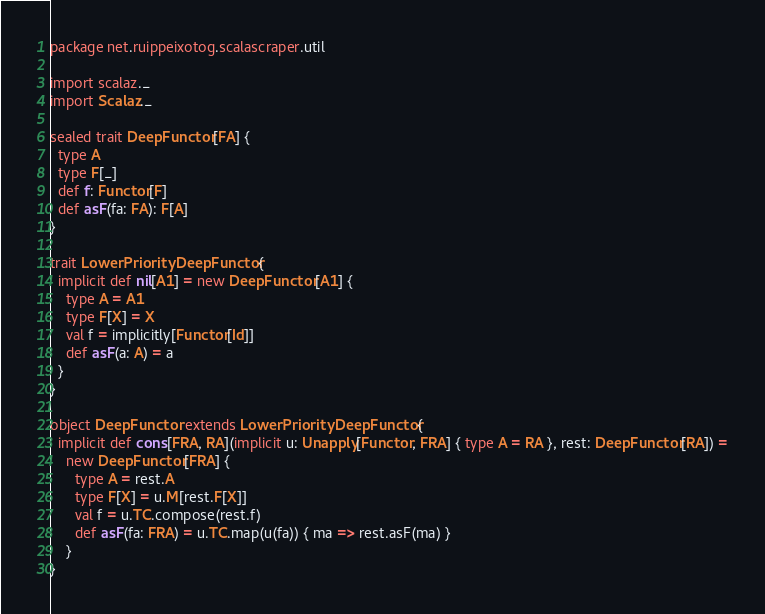<code> <loc_0><loc_0><loc_500><loc_500><_Scala_>package net.ruippeixotog.scalascraper.util

import scalaz._
import Scalaz._

sealed trait DeepFunctor[FA] {
  type A
  type F[_]
  def f: Functor[F]
  def asF(fa: FA): F[A]
}

trait LowerPriorityDeepFunctor {
  implicit def nil[A1] = new DeepFunctor[A1] {
    type A = A1
    type F[X] = X
    val f = implicitly[Functor[Id]]
    def asF(a: A) = a
  }
}

object DeepFunctor extends LowerPriorityDeepFunctor {
  implicit def cons[FRA, RA](implicit u: Unapply[Functor, FRA] { type A = RA }, rest: DeepFunctor[RA]) =
    new DeepFunctor[FRA] {
      type A = rest.A
      type F[X] = u.M[rest.F[X]]
      val f = u.TC.compose(rest.f)
      def asF(fa: FRA) = u.TC.map(u(fa)) { ma => rest.asF(ma) }
    }
}
</code> 